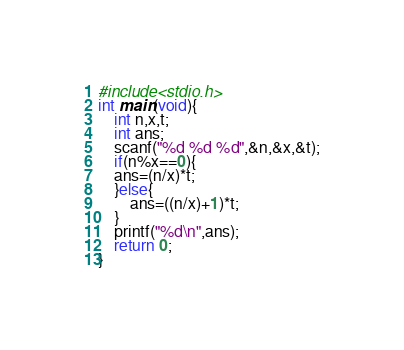<code> <loc_0><loc_0><loc_500><loc_500><_C_>#include<stdio.h>
int main(void){
    int n,x,t;
    int ans;
    scanf("%d %d %d",&n,&x,&t);
    if(n%x==0){
    ans=(n/x)*t;
    }else{
        ans=((n/x)+1)*t;
    }
    printf("%d\n",ans);
    return 0;
}</code> 